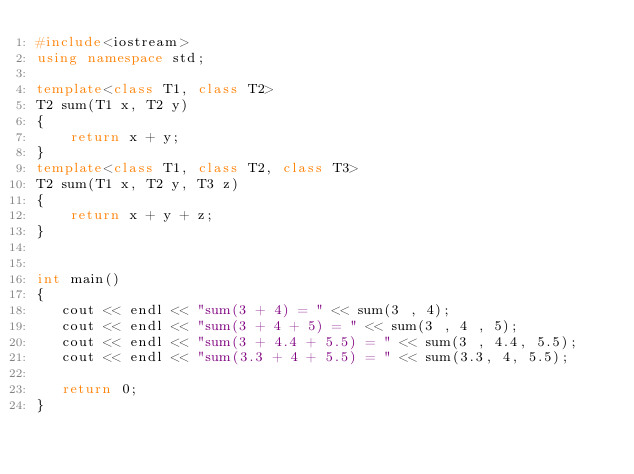Convert code to text. <code><loc_0><loc_0><loc_500><loc_500><_C++_>#include<iostream>
using namespace std;

template<class T1, class T2>
T2 sum(T1 x, T2 y)
{
    return x + y;
}
template<class T1, class T2, class T3>
T2 sum(T1 x, T2 y, T3 z)
{
    return x + y + z;
}


int main()
{
   cout << endl << "sum(3 + 4) = " << sum(3 , 4);
   cout << endl << "sum(3 + 4 + 5) = " << sum(3 , 4 , 5);
   cout << endl << "sum(3 + 4.4 + 5.5) = " << sum(3 , 4.4, 5.5);
   cout << endl << "sum(3.3 + 4 + 5.5) = " << sum(3.3, 4, 5.5);
   
   return 0;
}</code> 